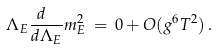Convert formula to latex. <formula><loc_0><loc_0><loc_500><loc_500>\Lambda _ { E } { \frac { d \ } { d \Lambda _ { E } } } m _ { E } ^ { 2 } \, = \, 0 + O ( g ^ { 6 } T ^ { 2 } ) \, .</formula> 